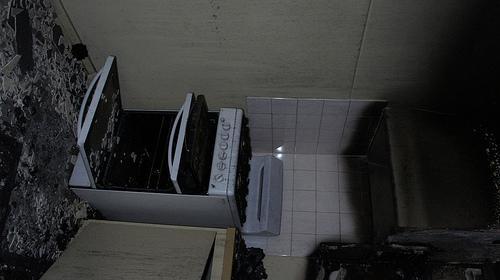How many oven doors are open?
Give a very brief answer. 2. 